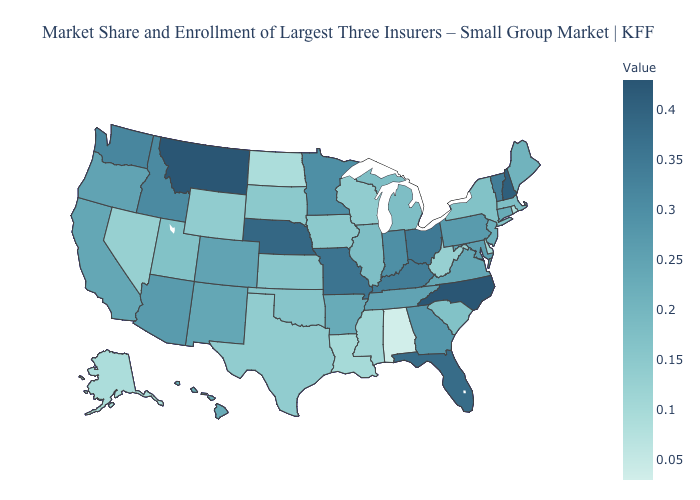Does Arkansas have the highest value in the South?
Give a very brief answer. No. Does Utah have a lower value than Alabama?
Quick response, please. No. Does New Mexico have the highest value in the West?
Short answer required. No. Does Alaska have the lowest value in the West?
Short answer required. Yes. Among the states that border Minnesota , does North Dakota have the lowest value?
Give a very brief answer. Yes. 